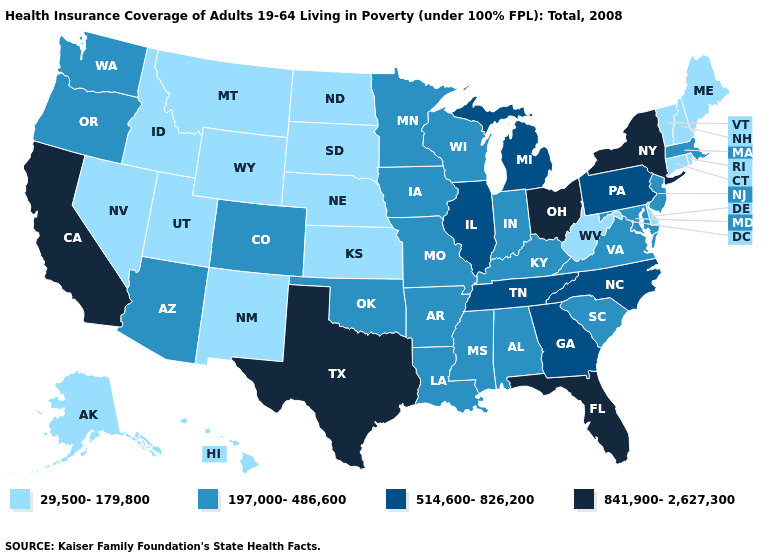What is the value of Arkansas?
Answer briefly. 197,000-486,600. Name the states that have a value in the range 841,900-2,627,300?
Keep it brief. California, Florida, New York, Ohio, Texas. Name the states that have a value in the range 29,500-179,800?
Keep it brief. Alaska, Connecticut, Delaware, Hawaii, Idaho, Kansas, Maine, Montana, Nebraska, Nevada, New Hampshire, New Mexico, North Dakota, Rhode Island, South Dakota, Utah, Vermont, West Virginia, Wyoming. Name the states that have a value in the range 514,600-826,200?
Be succinct. Georgia, Illinois, Michigan, North Carolina, Pennsylvania, Tennessee. Name the states that have a value in the range 197,000-486,600?
Give a very brief answer. Alabama, Arizona, Arkansas, Colorado, Indiana, Iowa, Kentucky, Louisiana, Maryland, Massachusetts, Minnesota, Mississippi, Missouri, New Jersey, Oklahoma, Oregon, South Carolina, Virginia, Washington, Wisconsin. Which states have the highest value in the USA?
Answer briefly. California, Florida, New York, Ohio, Texas. What is the value of Wyoming?
Be succinct. 29,500-179,800. Among the states that border Arkansas , does Oklahoma have the highest value?
Be succinct. No. What is the value of Texas?
Concise answer only. 841,900-2,627,300. Name the states that have a value in the range 197,000-486,600?
Give a very brief answer. Alabama, Arizona, Arkansas, Colorado, Indiana, Iowa, Kentucky, Louisiana, Maryland, Massachusetts, Minnesota, Mississippi, Missouri, New Jersey, Oklahoma, Oregon, South Carolina, Virginia, Washington, Wisconsin. What is the value of Montana?
Answer briefly. 29,500-179,800. Name the states that have a value in the range 197,000-486,600?
Keep it brief. Alabama, Arizona, Arkansas, Colorado, Indiana, Iowa, Kentucky, Louisiana, Maryland, Massachusetts, Minnesota, Mississippi, Missouri, New Jersey, Oklahoma, Oregon, South Carolina, Virginia, Washington, Wisconsin. Which states have the highest value in the USA?
Concise answer only. California, Florida, New York, Ohio, Texas. Name the states that have a value in the range 29,500-179,800?
Answer briefly. Alaska, Connecticut, Delaware, Hawaii, Idaho, Kansas, Maine, Montana, Nebraska, Nevada, New Hampshire, New Mexico, North Dakota, Rhode Island, South Dakota, Utah, Vermont, West Virginia, Wyoming. Which states have the lowest value in the USA?
Short answer required. Alaska, Connecticut, Delaware, Hawaii, Idaho, Kansas, Maine, Montana, Nebraska, Nevada, New Hampshire, New Mexico, North Dakota, Rhode Island, South Dakota, Utah, Vermont, West Virginia, Wyoming. 